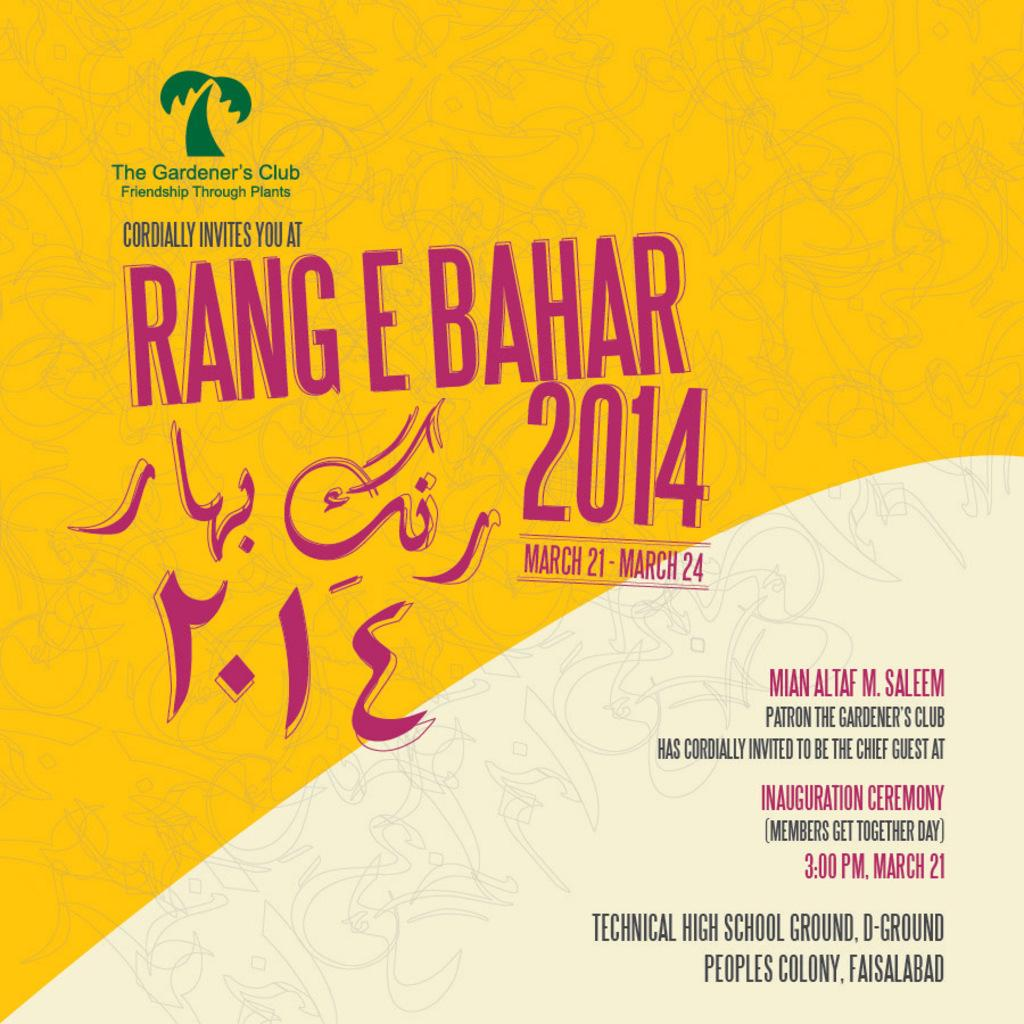<image>
Summarize the visual content of the image. CD album cover by artist Rang E Bahar 